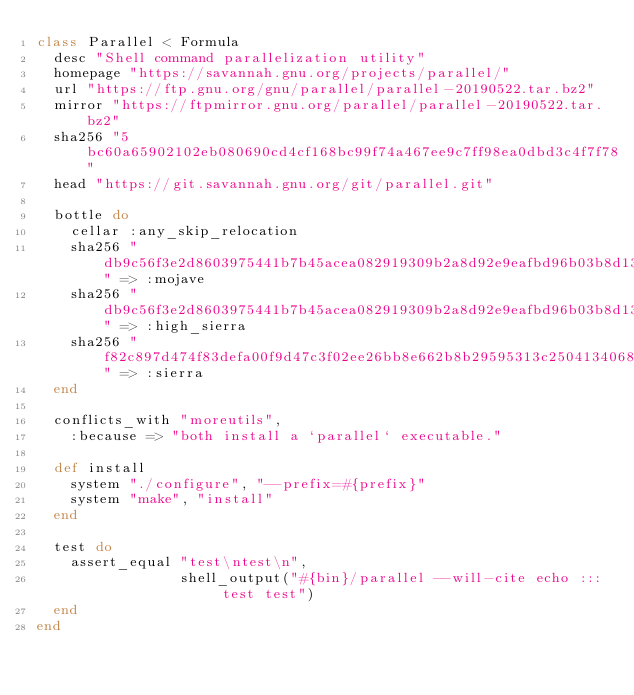Convert code to text. <code><loc_0><loc_0><loc_500><loc_500><_Ruby_>class Parallel < Formula
  desc "Shell command parallelization utility"
  homepage "https://savannah.gnu.org/projects/parallel/"
  url "https://ftp.gnu.org/gnu/parallel/parallel-20190522.tar.bz2"
  mirror "https://ftpmirror.gnu.org/parallel/parallel-20190522.tar.bz2"
  sha256 "5bc60a65902102eb080690cd4cf168bc99f74a467ee9c7ff98ea0dbd3c4f7f78"
  head "https://git.savannah.gnu.org/git/parallel.git"

  bottle do
    cellar :any_skip_relocation
    sha256 "db9c56f3e2d8603975441b7b45acea082919309b2a8d92e9eafbd96b03b8d13f" => :mojave
    sha256 "db9c56f3e2d8603975441b7b45acea082919309b2a8d92e9eafbd96b03b8d13f" => :high_sierra
    sha256 "f82c897d474f83defa00f9d47c3f02ee26bb8e662b8b29595313c2504134068d" => :sierra
  end

  conflicts_with "moreutils",
    :because => "both install a `parallel` executable."

  def install
    system "./configure", "--prefix=#{prefix}"
    system "make", "install"
  end

  test do
    assert_equal "test\ntest\n",
                 shell_output("#{bin}/parallel --will-cite echo ::: test test")
  end
end
</code> 